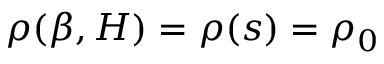Convert formula to latex. <formula><loc_0><loc_0><loc_500><loc_500>\rho ( \beta , H ) = \rho ( s ) = \rho _ { 0 }</formula> 